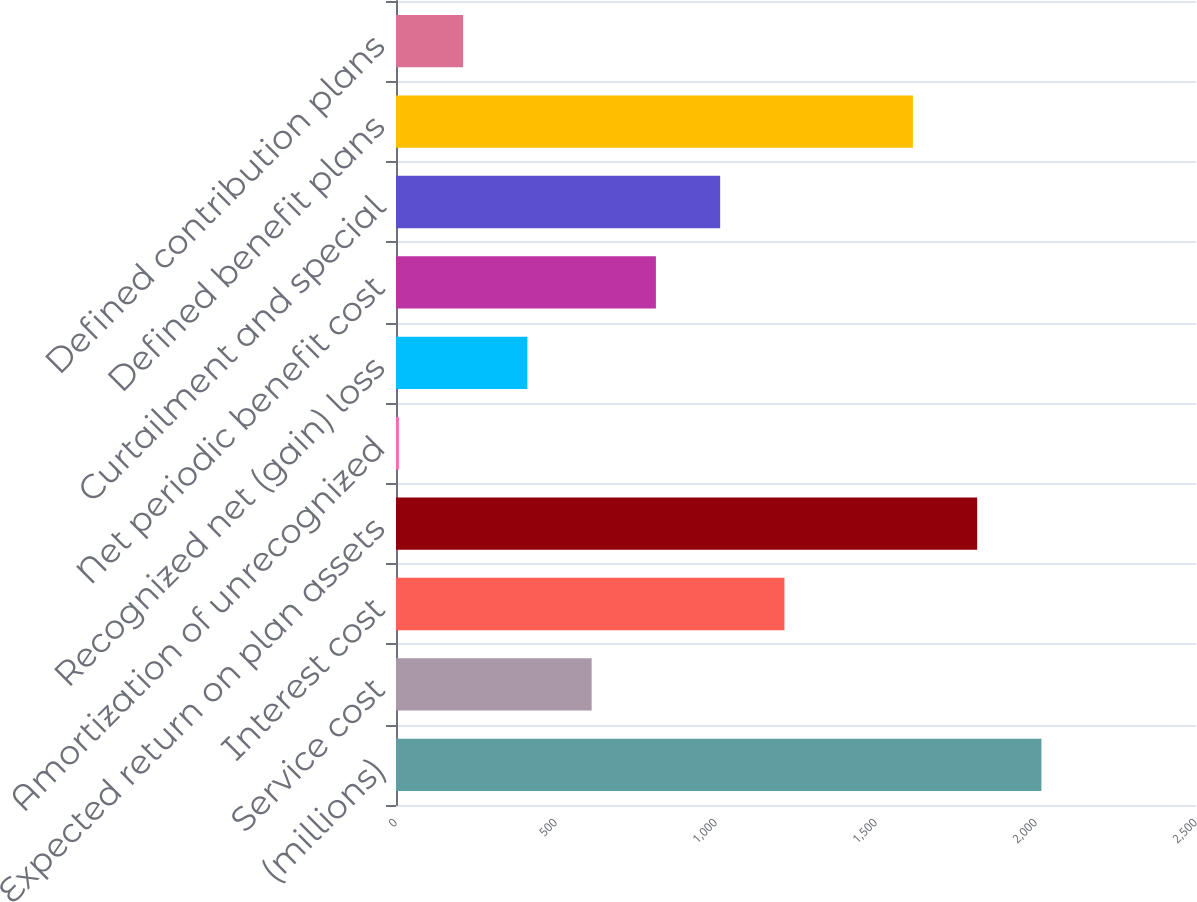<chart> <loc_0><loc_0><loc_500><loc_500><bar_chart><fcel>(millions)<fcel>Service cost<fcel>Interest cost<fcel>Expected return on plan assets<fcel>Amortization of unrecognized<fcel>Recognized net (gain) loss<fcel>Net periodic benefit cost<fcel>Curtailment and special<fcel>Defined benefit plans<fcel>Defined contribution plans<nl><fcel>2017<fcel>611.4<fcel>1213.8<fcel>1816.2<fcel>9<fcel>410.6<fcel>812.2<fcel>1013<fcel>1615.4<fcel>209.8<nl></chart> 